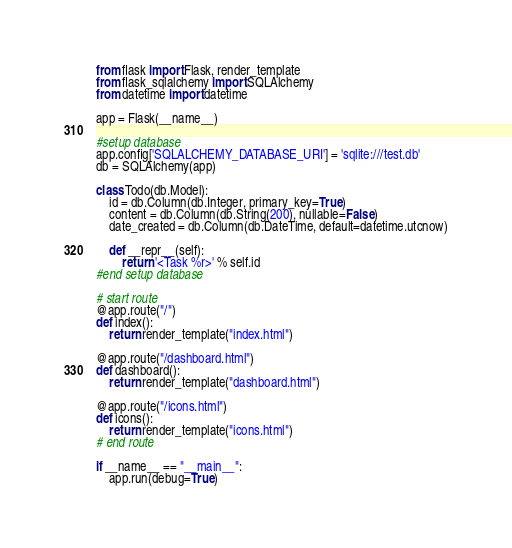Convert code to text. <code><loc_0><loc_0><loc_500><loc_500><_Python_>from flask import Flask, render_template
from flask_sqlalchemy import SQLAlchemy
from datetime import datetime

app = Flask(__name__)

#setup database
app.config['SQLALCHEMY_DATABASE_URI'] = 'sqlite:///test.db'
db = SQLAlchemy(app)

class Todo(db.Model):
    id = db.Column(db.Integer, primary_key=True)
    content = db.Column(db.String(200), nullable=False)
    date_created = db.Column(db.DateTime, default=datetime.utcnow)

    def __repr__(self):
        return '<Task %r>' % self.id
#end setup database

# start route
@app.route("/")
def index():
    return render_template("index.html")

@app.route("/dashboard.html")
def dashboard():
    return render_template("dashboard.html")

@app.route("/icons.html")
def icons():
    return render_template("icons.html")
# end route

if __name__ == "__main__":
    app.run(debug=True)</code> 